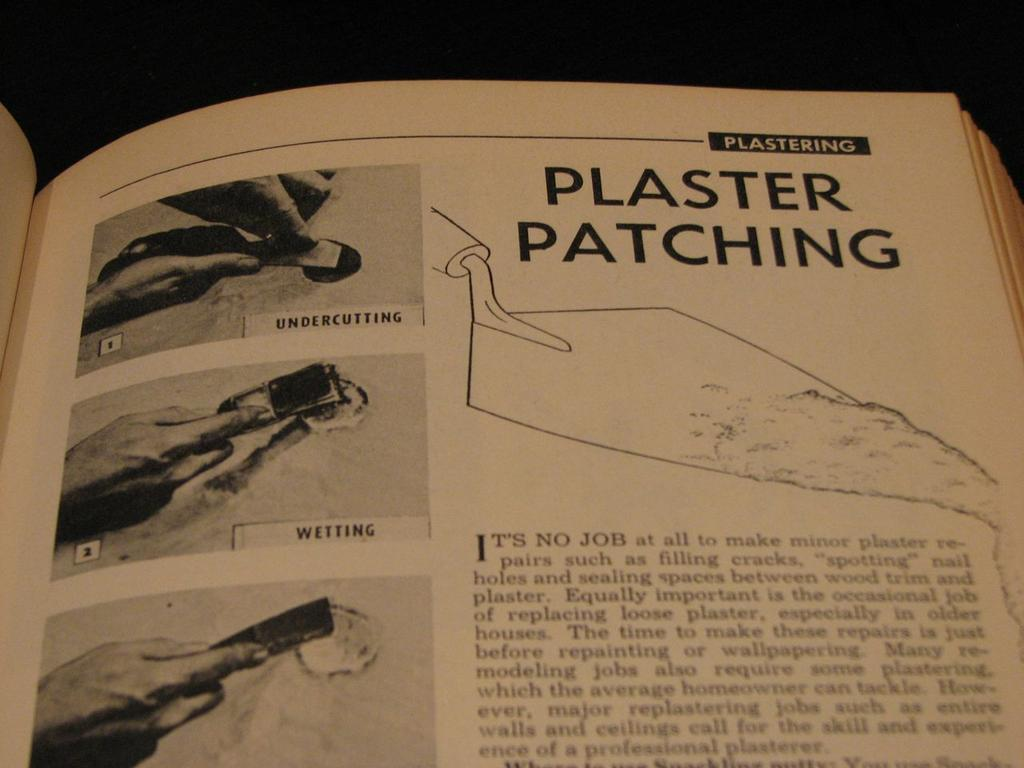Provide a one-sentence caption for the provided image. A book is opened to a page that talks about plaster patching and has pictures. 